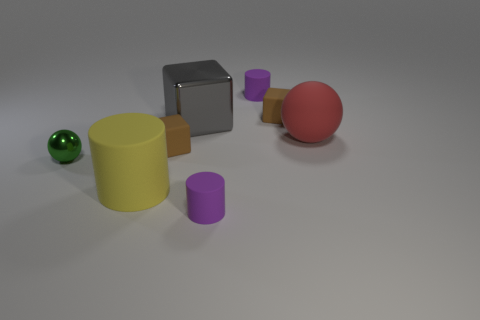Aside from the spheres, what other shapes can you identify? Besides the spheres, there are cylindrical and cubic objects. Specifically, one large yellow cylinder, one small purple cylinder, and a gray cube. 